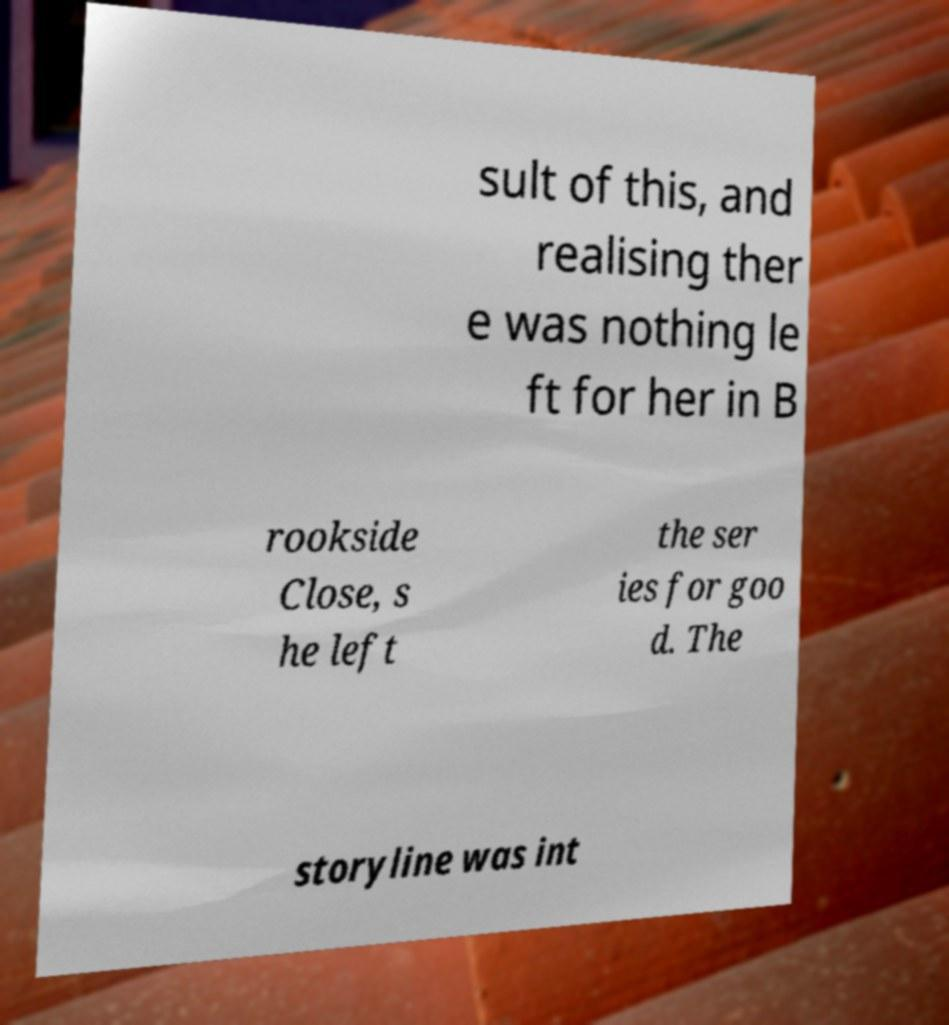I need the written content from this picture converted into text. Can you do that? sult of this, and realising ther e was nothing le ft for her in B rookside Close, s he left the ser ies for goo d. The storyline was int 